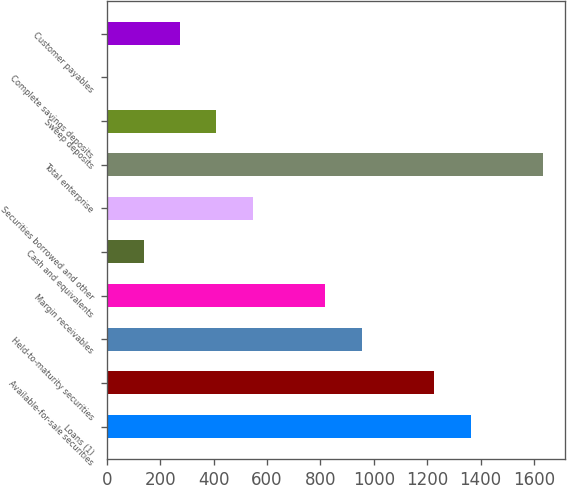<chart> <loc_0><loc_0><loc_500><loc_500><bar_chart><fcel>Loans (1)<fcel>Available-for-sale securities<fcel>Held-to-maturity securities<fcel>Margin receivables<fcel>Cash and equivalents<fcel>Securities borrowed and other<fcel>Total enterprise<fcel>Sweep deposits<fcel>Complete savings deposits<fcel>Customer payables<nl><fcel>1363<fcel>1227<fcel>955<fcel>819<fcel>139<fcel>547<fcel>1635<fcel>411<fcel>3<fcel>275<nl></chart> 